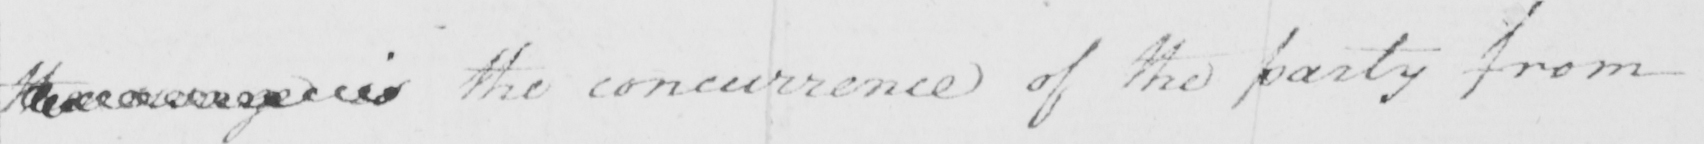Can you tell me what this handwritten text says? the  <gap/>  is The concurrence of the party from 